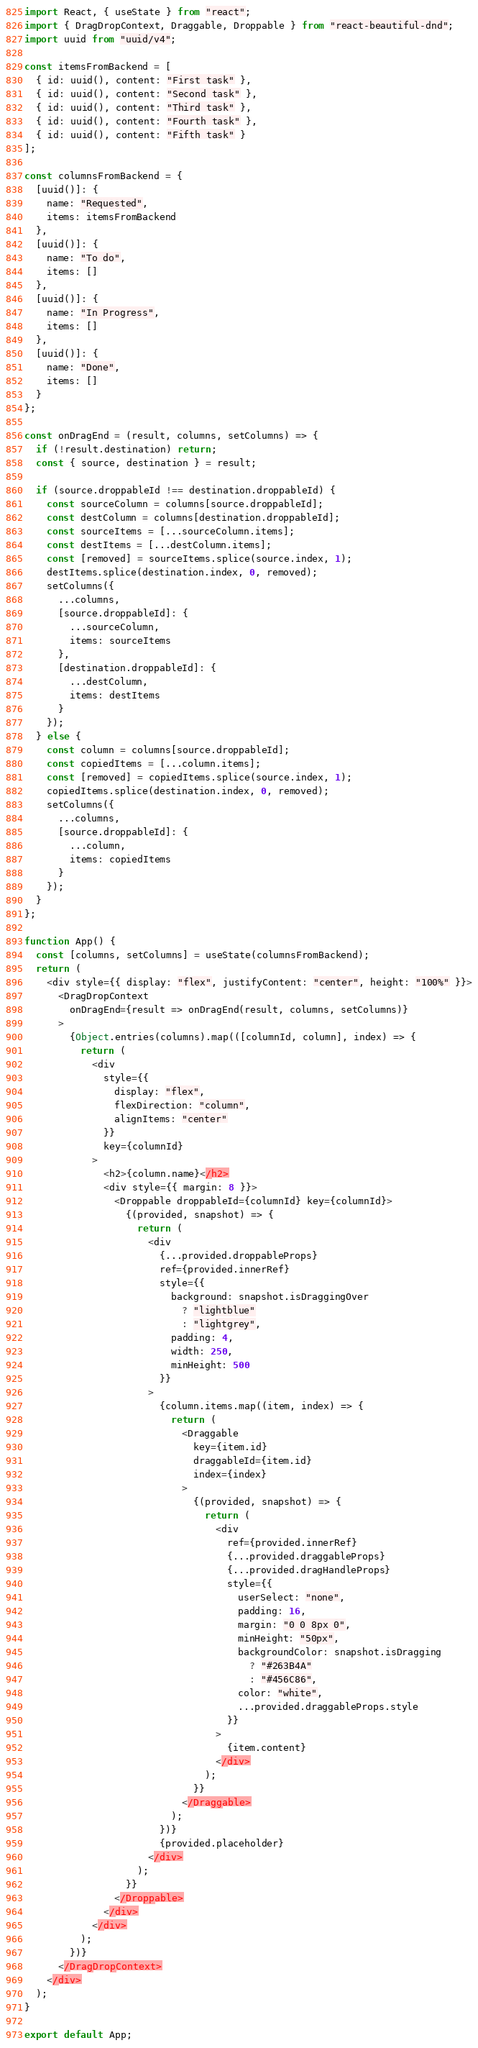Convert code to text. <code><loc_0><loc_0><loc_500><loc_500><_JavaScript_>import React, { useState } from "react";
import { DragDropContext, Draggable, Droppable } from "react-beautiful-dnd";
import uuid from "uuid/v4";

const itemsFromBackend = [
  { id: uuid(), content: "First task" },
  { id: uuid(), content: "Second task" },
  { id: uuid(), content: "Third task" },
  { id: uuid(), content: "Fourth task" },
  { id: uuid(), content: "Fifth task" }
];

const columnsFromBackend = {
  [uuid()]: {
    name: "Requested",
    items: itemsFromBackend
  },
  [uuid()]: {
    name: "To do",
    items: []
  },
  [uuid()]: {
    name: "In Progress",
    items: []
  },
  [uuid()]: {
    name: "Done",
    items: []
  }
};

const onDragEnd = (result, columns, setColumns) => {
  if (!result.destination) return;
  const { source, destination } = result;

  if (source.droppableId !== destination.droppableId) {
    const sourceColumn = columns[source.droppableId];
    const destColumn = columns[destination.droppableId];
    const sourceItems = [...sourceColumn.items];
    const destItems = [...destColumn.items];
    const [removed] = sourceItems.splice(source.index, 1);
    destItems.splice(destination.index, 0, removed);
    setColumns({
      ...columns,
      [source.droppableId]: {
        ...sourceColumn,
        items: sourceItems
      },
      [destination.droppableId]: {
        ...destColumn,
        items: destItems
      }
    });
  } else {
    const column = columns[source.droppableId];
    const copiedItems = [...column.items];
    const [removed] = copiedItems.splice(source.index, 1);
    copiedItems.splice(destination.index, 0, removed);
    setColumns({
      ...columns,
      [source.droppableId]: {
        ...column,
        items: copiedItems
      }
    });
  }
};

function App() {
  const [columns, setColumns] = useState(columnsFromBackend);
  return (
    <div style={{ display: "flex", justifyContent: "center", height: "100%" }}>
      <DragDropContext
        onDragEnd={result => onDragEnd(result, columns, setColumns)}
      >
        {Object.entries(columns).map(([columnId, column], index) => {
          return (
            <div
              style={{
                display: "flex",
                flexDirection: "column",
                alignItems: "center"
              }}
              key={columnId}
            >
              <h2>{column.name}</h2>
              <div style={{ margin: 8 }}>
                <Droppable droppableId={columnId} key={columnId}>
                  {(provided, snapshot) => {
                    return (
                      <div
                        {...provided.droppableProps}
                        ref={provided.innerRef}
                        style={{
                          background: snapshot.isDraggingOver
                            ? "lightblue"
                            : "lightgrey",
                          padding: 4,
                          width: 250,
                          minHeight: 500
                        }}
                      >
                        {column.items.map((item, index) => {
                          return (
                            <Draggable
                              key={item.id}
                              draggableId={item.id}
                              index={index}
                            >
                              {(provided, snapshot) => {
                                return (
                                  <div
                                    ref={provided.innerRef}
                                    {...provided.draggableProps}
                                    {...provided.dragHandleProps}
                                    style={{
                                      userSelect: "none",
                                      padding: 16,
                                      margin: "0 0 8px 0",
                                      minHeight: "50px",
                                      backgroundColor: snapshot.isDragging
                                        ? "#263B4A"
                                        : "#456C86",
                                      color: "white",
                                      ...provided.draggableProps.style
                                    }}
                                  >
                                    {item.content}
                                  </div>
                                );
                              }}
                            </Draggable>
                          );
                        })}
                        {provided.placeholder}
                      </div>
                    );
                  }}
                </Droppable>
              </div>
            </div>
          );
        })}
      </DragDropContext>
    </div>
  );
}

export default App;
</code> 